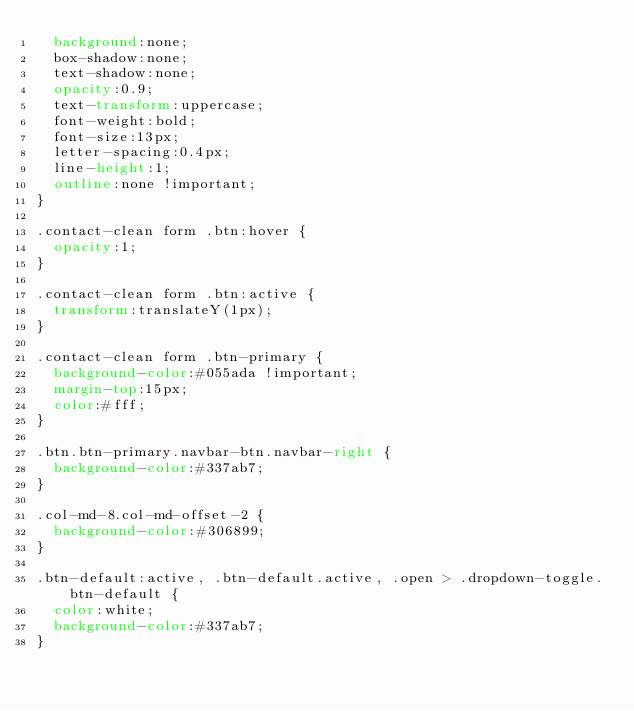Convert code to text. <code><loc_0><loc_0><loc_500><loc_500><_CSS_>  background:none;
  box-shadow:none;
  text-shadow:none;
  opacity:0.9;
  text-transform:uppercase;
  font-weight:bold;
  font-size:13px;
  letter-spacing:0.4px;
  line-height:1;
  outline:none !important;
}

.contact-clean form .btn:hover {
  opacity:1;
}

.contact-clean form .btn:active {
  transform:translateY(1px);
}

.contact-clean form .btn-primary {
  background-color:#055ada !important;
  margin-top:15px;
  color:#fff;
}

.btn.btn-primary.navbar-btn.navbar-right {
  background-color:#337ab7;
}

.col-md-8.col-md-offset-2 {
  background-color:#306899;
}

.btn-default:active, .btn-default.active, .open > .dropdown-toggle.btn-default {
  color:white;
  background-color:#337ab7;
}

</code> 